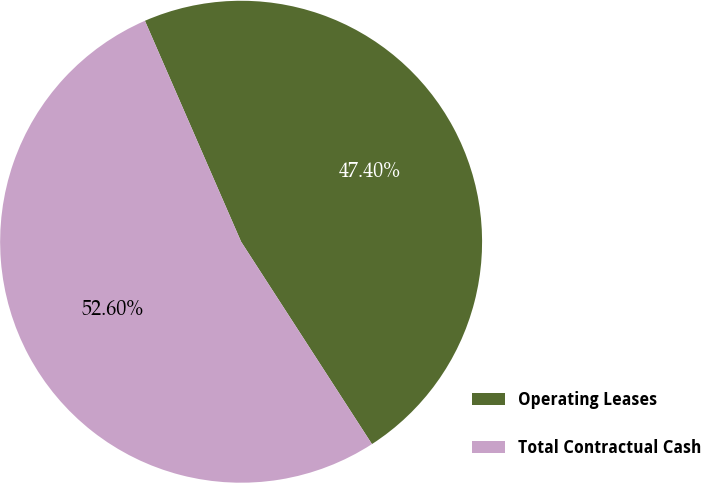Convert chart to OTSL. <chart><loc_0><loc_0><loc_500><loc_500><pie_chart><fcel>Operating Leases<fcel>Total Contractual Cash<nl><fcel>47.4%<fcel>52.6%<nl></chart> 